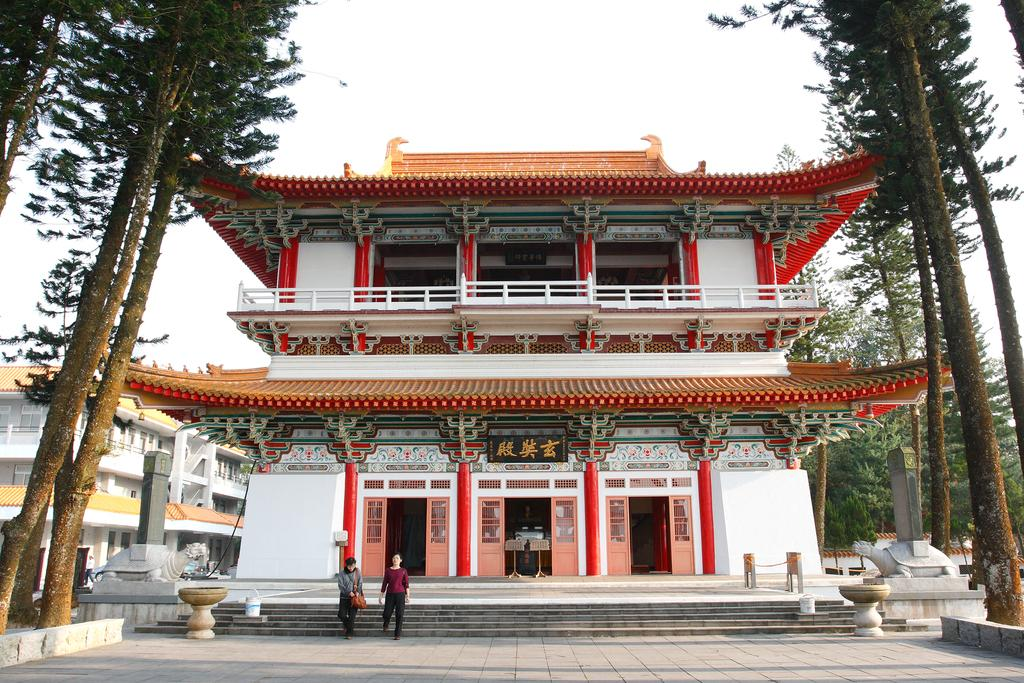What is the main subject of the image? The main subject of the image is the buildings at the center. What are the people in the image doing? Two persons are walking in front of the buildings. Can you describe the ground in the image? The floor is visible in the image. What can be seen in the background of the image? There are trees and the sky visible in the background. Can you tell me how many times the horn sounds in the image? There is no horn present in the image, so it cannot be determined how many times it sounds. What type of volleyball game is being played in the image? There is no volleyball game present in the image; it features buildings, people walking, and a background with trees and the sky. 